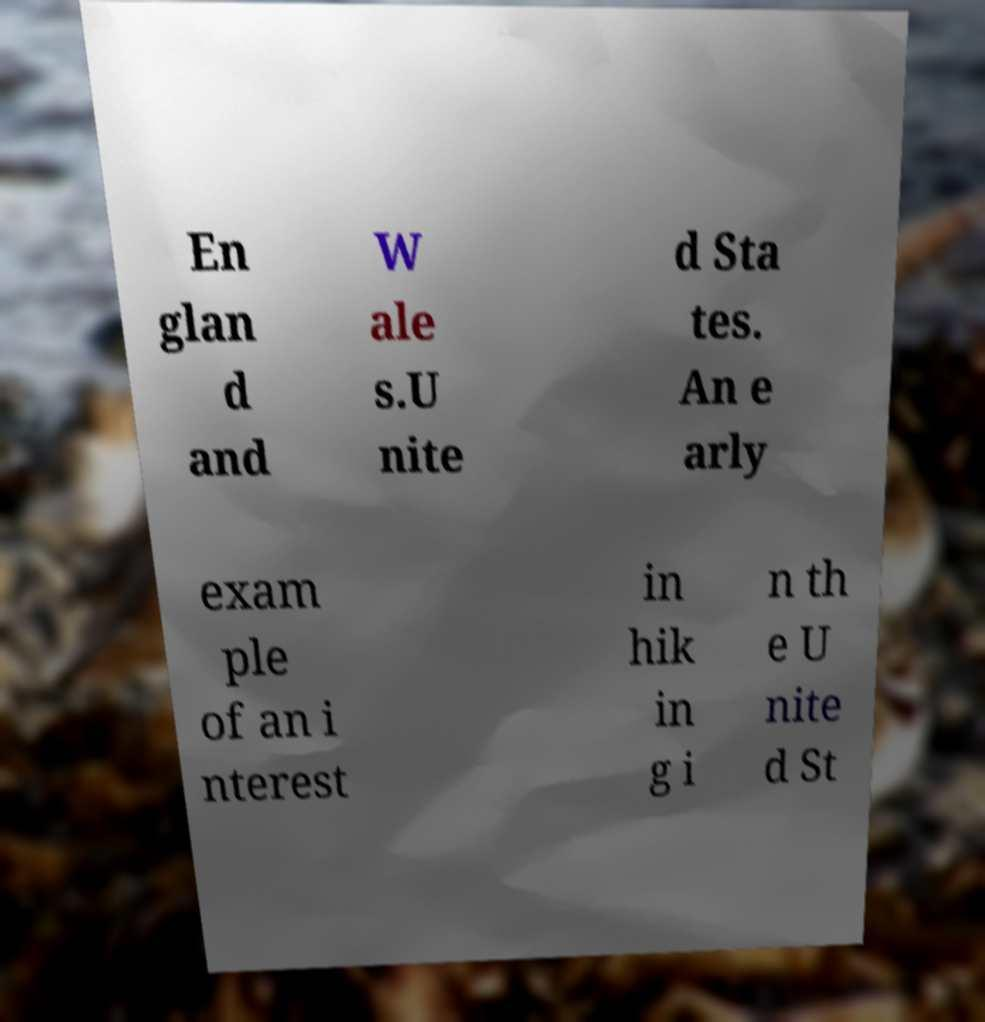Can you accurately transcribe the text from the provided image for me? En glan d and W ale s.U nite d Sta tes. An e arly exam ple of an i nterest in hik in g i n th e U nite d St 